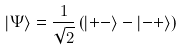Convert formula to latex. <formula><loc_0><loc_0><loc_500><loc_500>\left | \Psi \right \rangle = \frac { 1 } { \sqrt { 2 } } \left ( \left | + - \right \rangle - \left | - + \right \rangle \right )</formula> 